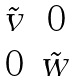Convert formula to latex. <formula><loc_0><loc_0><loc_500><loc_500>\begin{matrix} \tilde { v } & 0 \\ 0 & \tilde { w } \end{matrix}</formula> 